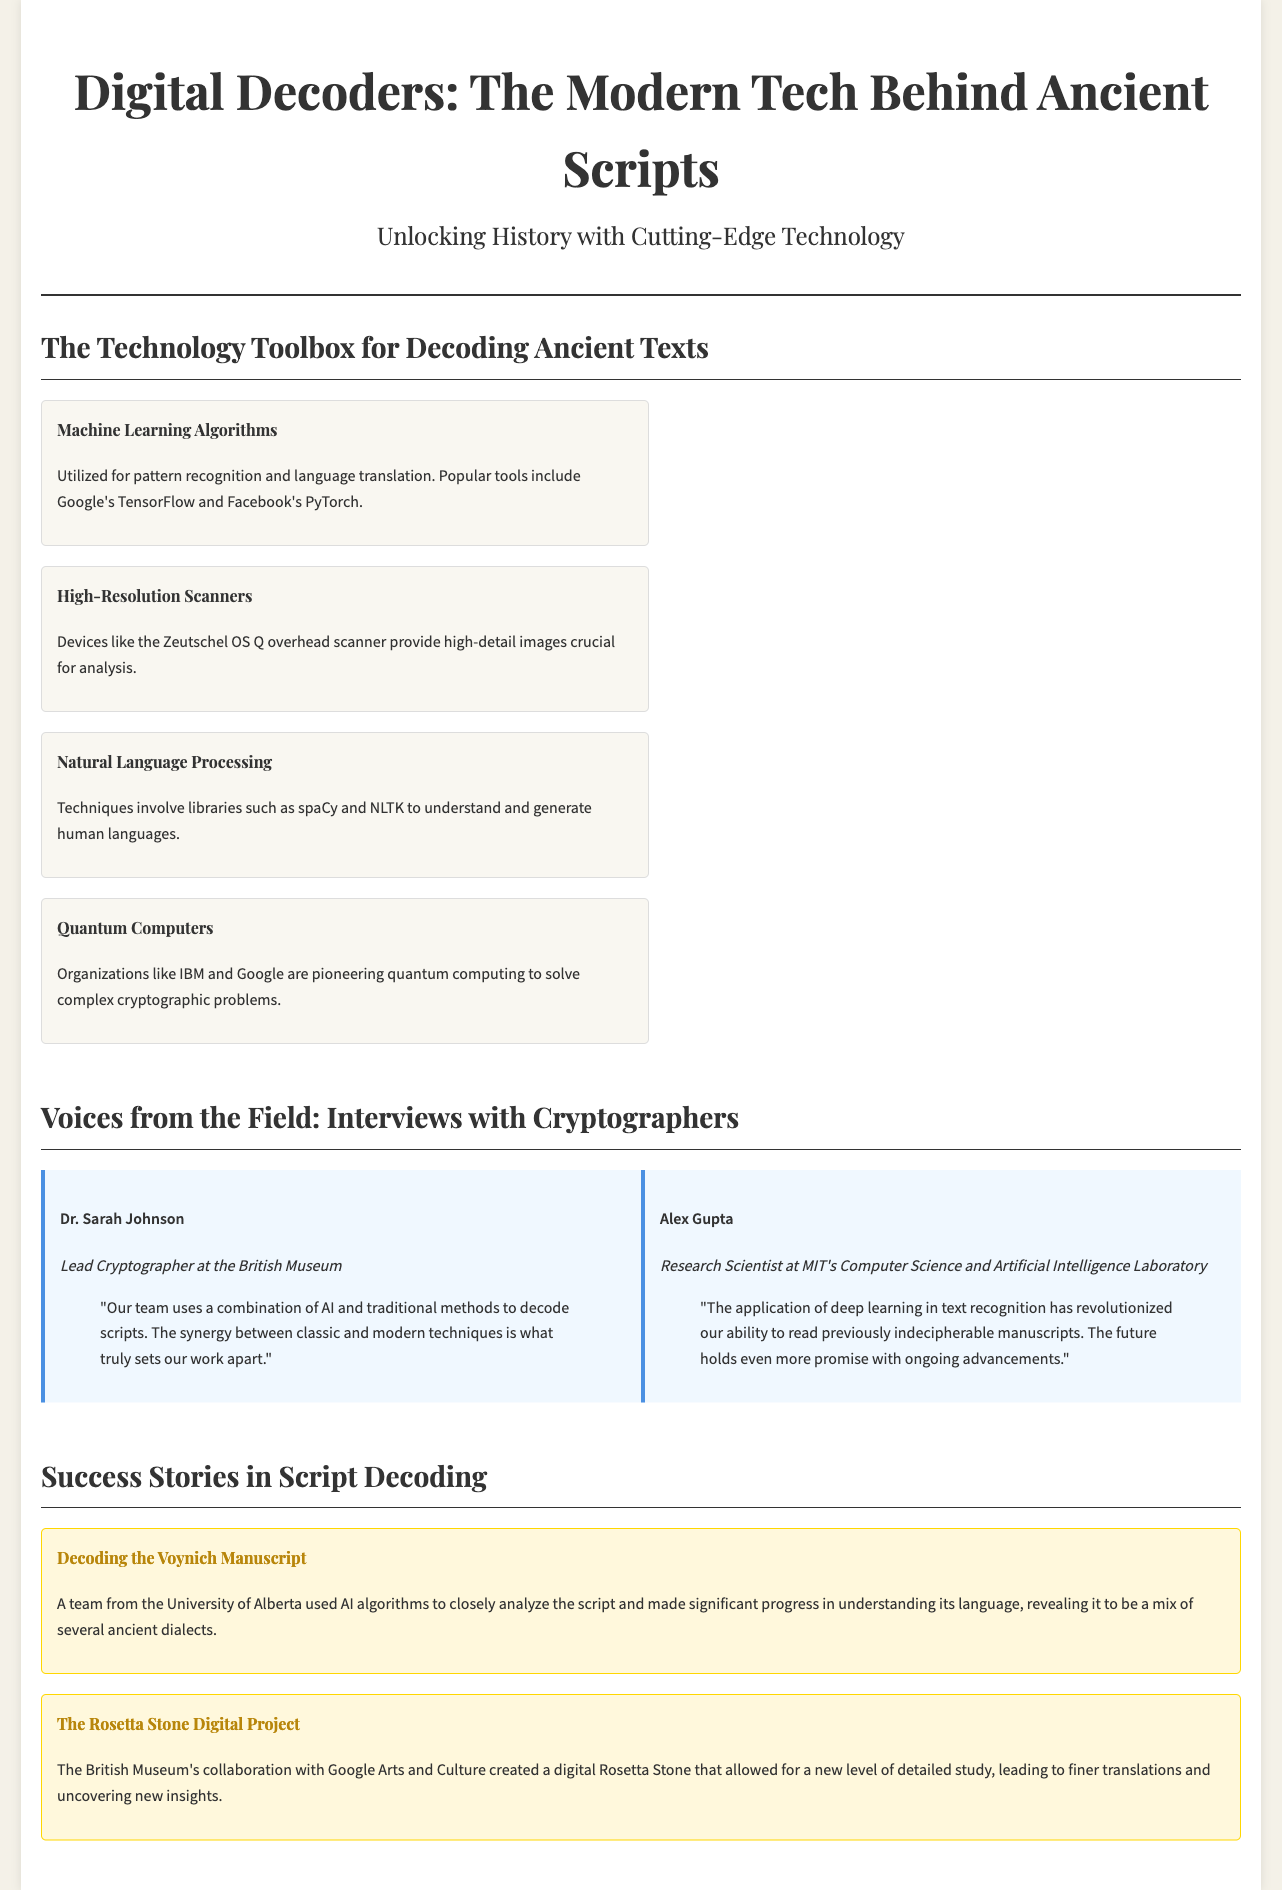What algorithms are mentioned in the technology toolbox? The document lists machine learning algorithms as a key technology for decoding.
Answer: Machine Learning Algorithms Who is the lead cryptographer at the British Museum? The document identifies Dr. Sarah Johnson as the lead cryptographer at the British Museum.
Answer: Dr. Sarah Johnson What technology did the University of Alberta use to decode the Voynich Manuscript? The document specifies that AI algorithms were utilized by the University of Alberta's team to analyze the Voynich Manuscript.
Answer: AI algorithms Which organizations are pioneering quantum computing? The document mentions IBM and Google as organizations that are pioneering quantum computing.
Answer: IBM and Google What does Alex Gupta state has been revolutionized by deep learning? According to the document, deep learning has revolutionized text recognition.
Answer: Text recognition How many success stories are highlighted in the document? The document highlights two success stories in script decoding.
Answer: Two What is the purpose of high-resolution scanners according to the document? The document states that high-resolution scanners provide high-detail images crucial for analysis.
Answer: High-detail images Which collaboration created a digital Rosetta Stone? The document mentions the British Museum's collaboration with Google Arts and Culture.
Answer: British Museum and Google Arts and Culture What is the background color of the displayed newspaper? The document describes the background color of the newspaper layout as white.
Answer: White 